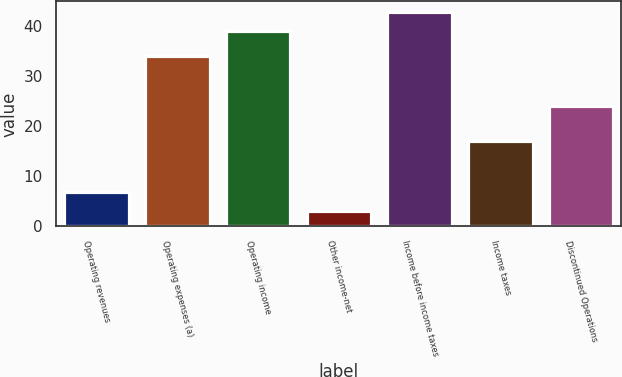<chart> <loc_0><loc_0><loc_500><loc_500><bar_chart><fcel>Operating revenues<fcel>Operating expenses (a)<fcel>Operating income<fcel>Other income-net<fcel>Income before income taxes<fcel>Income taxes<fcel>Discontinued Operations<nl><fcel>6.8<fcel>34<fcel>39<fcel>3<fcel>42.8<fcel>17<fcel>24<nl></chart> 